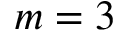<formula> <loc_0><loc_0><loc_500><loc_500>m = 3</formula> 